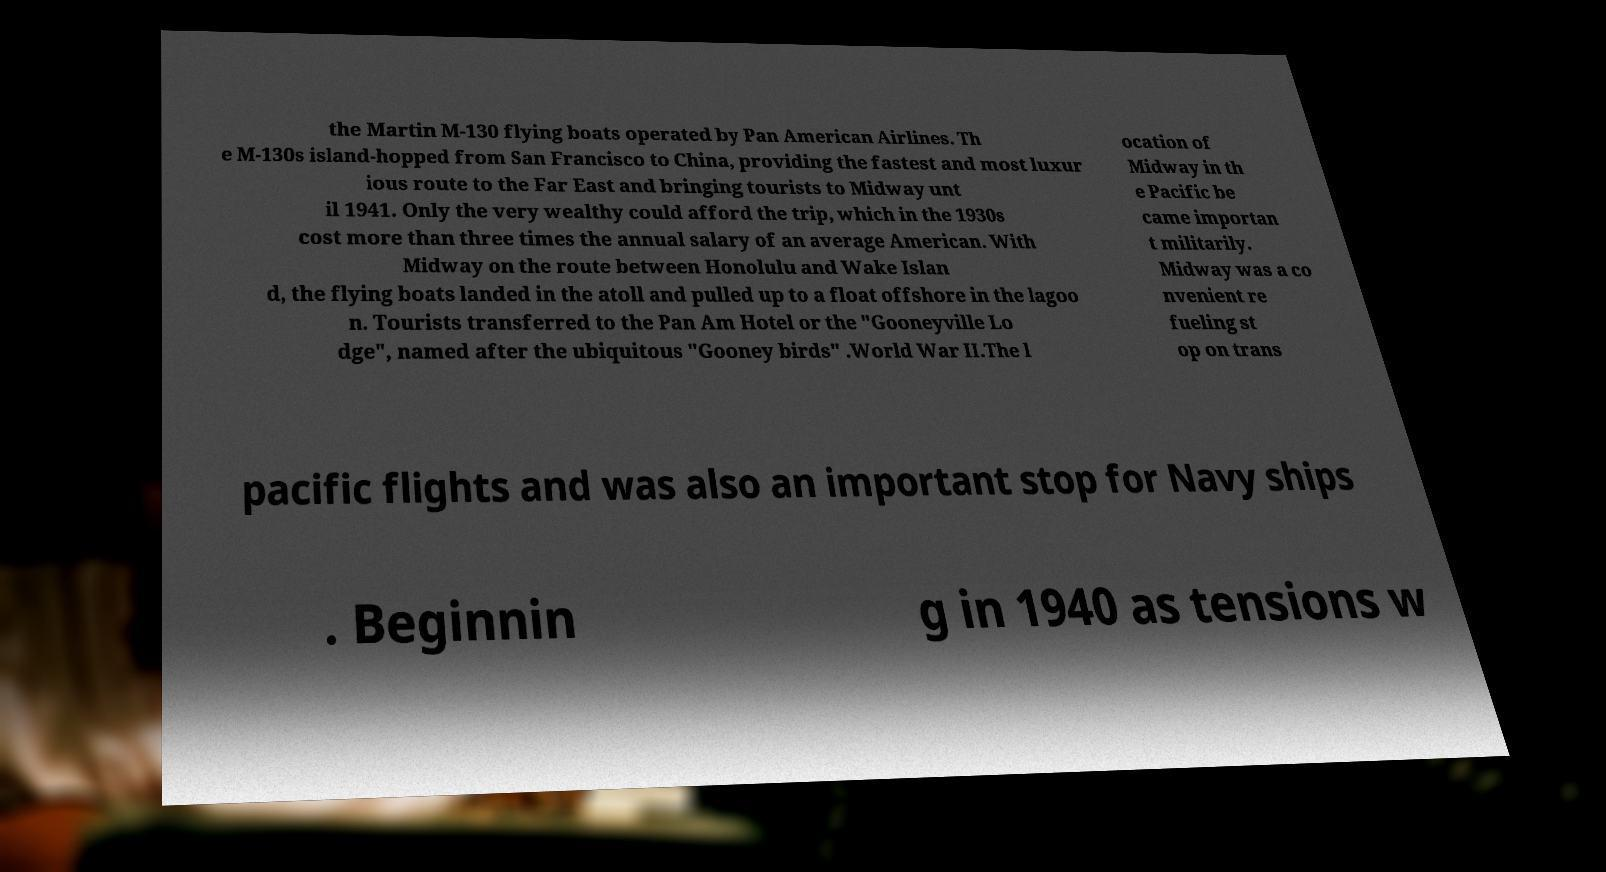There's text embedded in this image that I need extracted. Can you transcribe it verbatim? the Martin M-130 flying boats operated by Pan American Airlines. Th e M-130s island-hopped from San Francisco to China, providing the fastest and most luxur ious route to the Far East and bringing tourists to Midway unt il 1941. Only the very wealthy could afford the trip, which in the 1930s cost more than three times the annual salary of an average American. With Midway on the route between Honolulu and Wake Islan d, the flying boats landed in the atoll and pulled up to a float offshore in the lagoo n. Tourists transferred to the Pan Am Hotel or the "Gooneyville Lo dge", named after the ubiquitous "Gooney birds" .World War II.The l ocation of Midway in th e Pacific be came importan t militarily. Midway was a co nvenient re fueling st op on trans pacific flights and was also an important stop for Navy ships . Beginnin g in 1940 as tensions w 